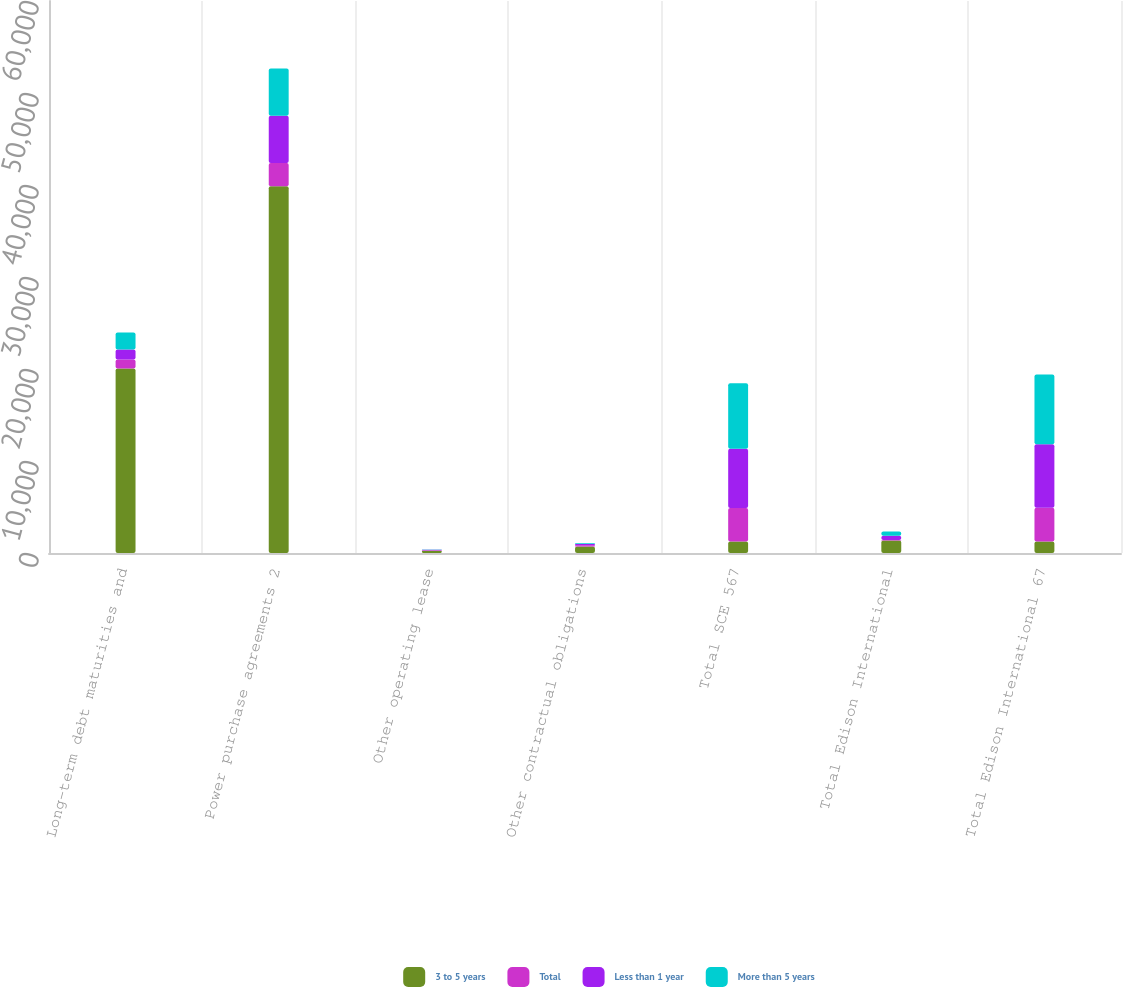Convert chart. <chart><loc_0><loc_0><loc_500><loc_500><stacked_bar_chart><ecel><fcel>Long-term debt maturities and<fcel>Power purchase agreements 2<fcel>Other operating lease<fcel>Other contractual obligations<fcel>Total SCE 567<fcel>Total Edison International<fcel>Total Edison International 67<nl><fcel>3 to 5 years<fcel>20060<fcel>39877<fcel>246<fcel>704<fcel>1236.5<fcel>1370<fcel>1236.5<nl><fcel>Total<fcel>967<fcel>2513<fcel>48<fcel>127<fcel>3655<fcel>35<fcel>3690<nl><fcel>Less than 1 year<fcel>1103<fcel>5127<fcel>64<fcel>141<fcel>6435<fcel>462<fcel>6897<nl><fcel>More than 5 years<fcel>1844<fcel>5144<fcel>35<fcel>91<fcel>7114<fcel>459<fcel>7573<nl></chart> 